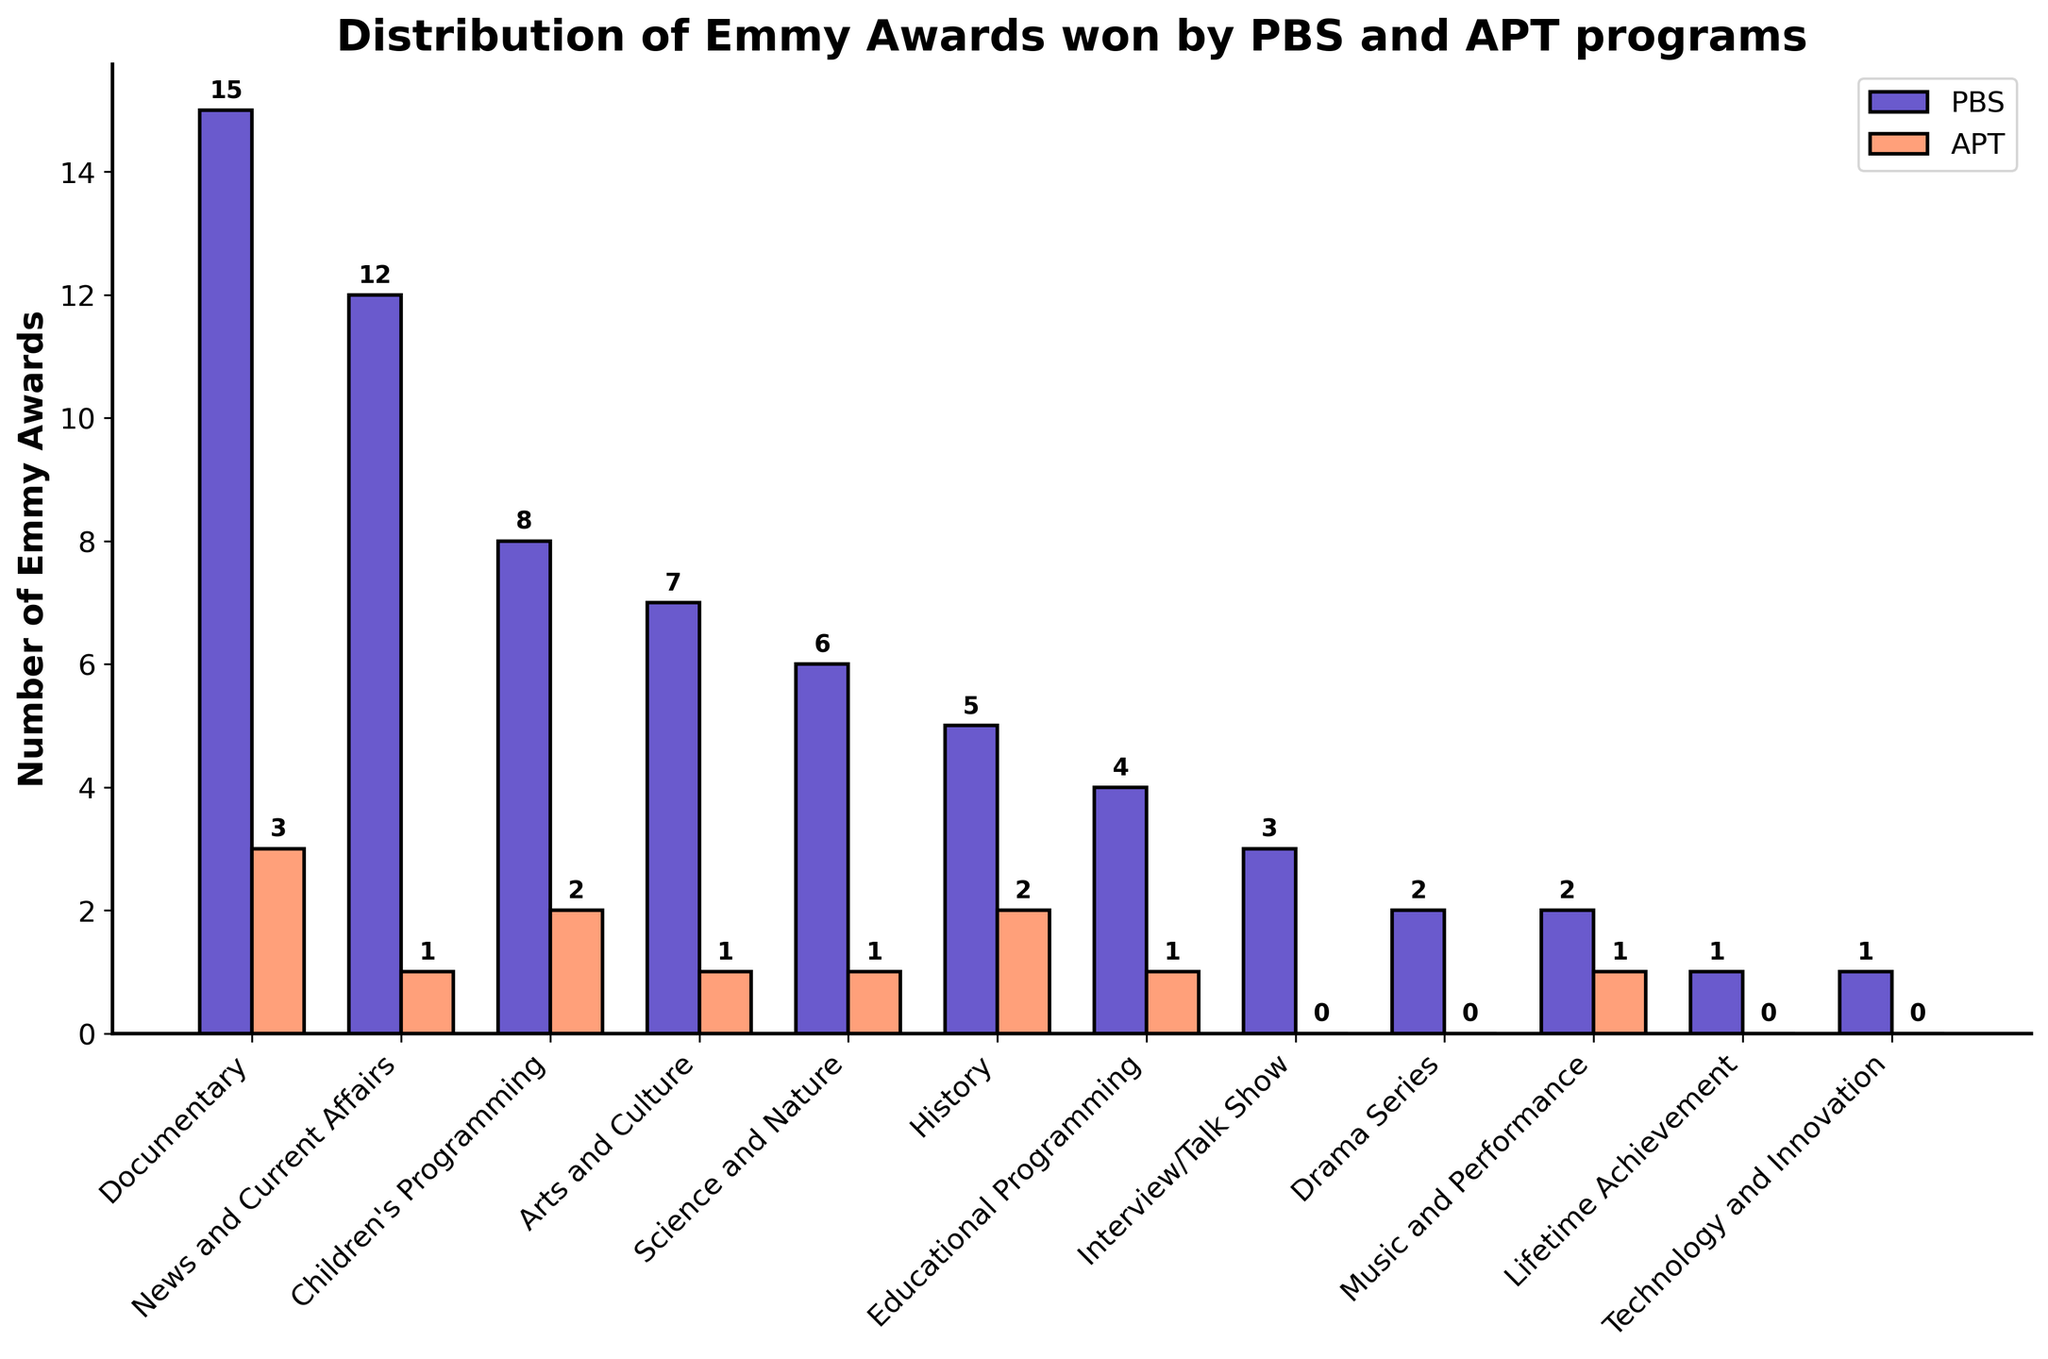Which category has the highest number of Emmy Awards for PBS? The tallest bar representing PBS is in the Documentary category.
Answer: Documentary How many more Emmy Awards has PBS won in Children's Programming compared to APT? PBS has 8 Emmy Awards in Children's Programming, while APT has 2. The difference is 8 - 2.
Answer: 6 Which categories show equal numbers of Emmy Awards for both PBS and APT? By comparing the bars, we see that no category has equal numbers of awards for both PBS and APT.
Answer: None What is the total number of Emmy Awards won by APT across all categories? Summing APT's values: 3 + 1 + 2 + 1 + 1 + 2 + 1 + 0 + 0 + 1 + 0 + 0 = 12
Answer: 12 What is the ratio of Emmy Awards won in the Documentary category to those in the Lifetime Achievement category for PBS? PBS has 15 awards in Documentary and 1 in Lifetime Achievement. The ratio is 15:1.
Answer: 15:1 Which category has the smallest combined number of Emmy Awards for PBS and APT? Summing the bar heights for each category, Technology and Innovation has the smallest combined count (1+0=1).
Answer: Technology and Innovation How many total Emmy Awards have PBS and APT won in the History category combined? PBS and APT have 5 and 2 awards in History, respectively. The total is 5 + 2.
Answer: 7 In which category does APT have the second-highest number of Emmy Awards won? APT's highest is in Documentary (3). The second-highest is two categories: History, and Children’s Programming have 2 awards each.
Answer: History and Children’s Programming What is the difference in the total number of Emmy Awards between PBS and APT? Summing PBS's awards: 15+12+8+7+6+5+4+3+2+2+1+1 = 66. Summing APT's awards: 3+1+2+1+1+2+1+0+0+1+0+0 = 12. The difference is 66 - 12.
Answer: 54 Which category shows the closest number of Emmy Awards between PBS and APT? By comparing the differences in each category, "Music and Performance" shows the closest numbers with 2 awards for PBS and 1 for APT.
Answer: Music and Performance 